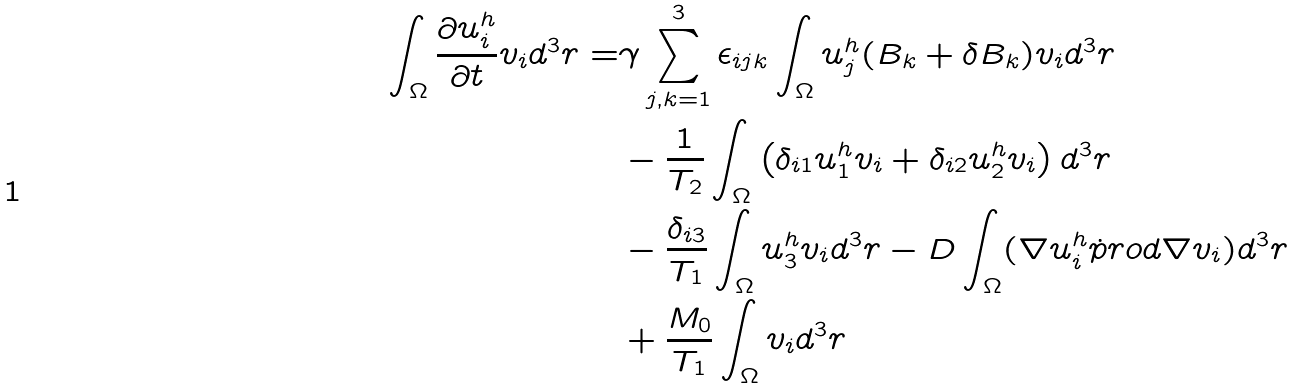Convert formula to latex. <formula><loc_0><loc_0><loc_500><loc_500>\int _ { \Omega } \frac { \partial u _ { i } ^ { h } } { \partial t } v _ { i } d ^ { 3 } r = & \gamma \sum _ { j , k = 1 } ^ { 3 } \epsilon _ { i j k } \int _ { \Omega } u _ { j } ^ { h } ( B _ { k } + \delta B _ { k } ) v _ { i } d ^ { 3 } r \\ & - \frac { 1 } { T _ { 2 } } \int _ { \Omega } \left ( \delta _ { i 1 } u _ { 1 } ^ { h } v _ { i } + \delta _ { i 2 } u _ { 2 } ^ { h } v _ { i } \right ) d ^ { 3 } r \\ & - \frac { \delta _ { i 3 } } { T _ { 1 } } \int _ { \Omega } u _ { 3 } ^ { h } v _ { i } d ^ { 3 } r - D \int _ { \Omega } ( \nabla u _ { i } ^ { h } \dot { p } r o d \nabla v _ { i } ) d ^ { 3 } r \\ & + \frac { M _ { 0 } } { T _ { 1 } } \int _ { \Omega } v _ { i } d ^ { 3 } r</formula> 